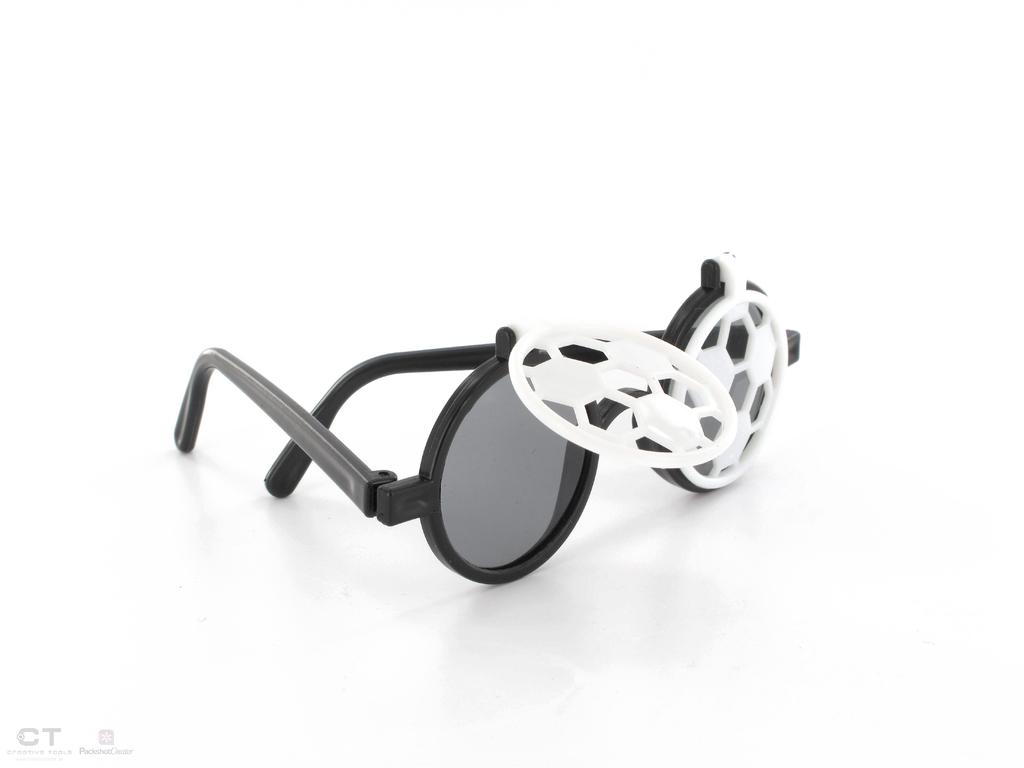What object can be seen in the image? There are goggles in the image. What color is the background of the image? The background of the image is white. Where is the rabbit sitting in the image? There is no rabbit present in the image. What type of bean is being used as a prop in the image? There are no beans present in the image. 